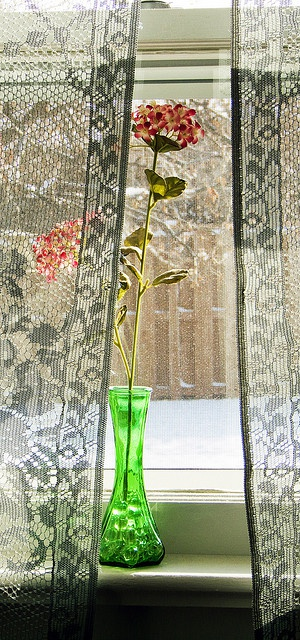Describe the objects in this image and their specific colors. I can see a vase in lightgray, darkgreen, lime, and green tones in this image. 